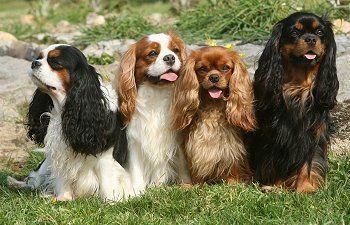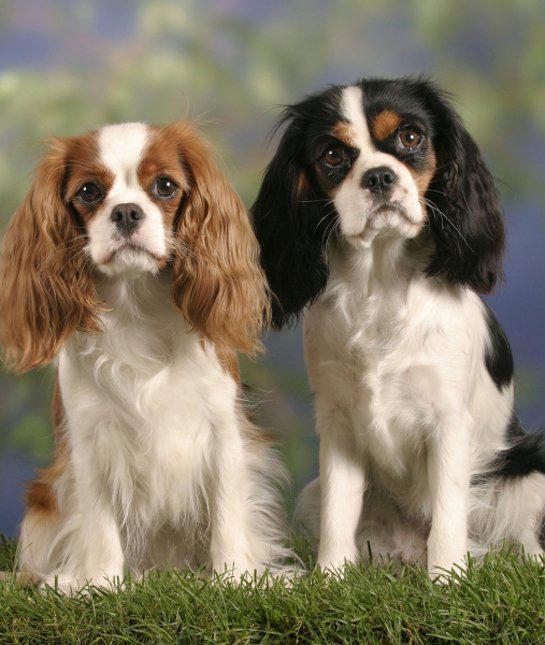The first image is the image on the left, the second image is the image on the right. Assess this claim about the two images: "In one image, there is one brown and white dog and one black, white and brown dog sitting side by side outdoors while staring straight ahead at the camera". Correct or not? Answer yes or no. Yes. The first image is the image on the left, the second image is the image on the right. Analyze the images presented: Is the assertion "An image shows a horizontal row of four different-colored dogs sitting on the grass." valid? Answer yes or no. Yes. 